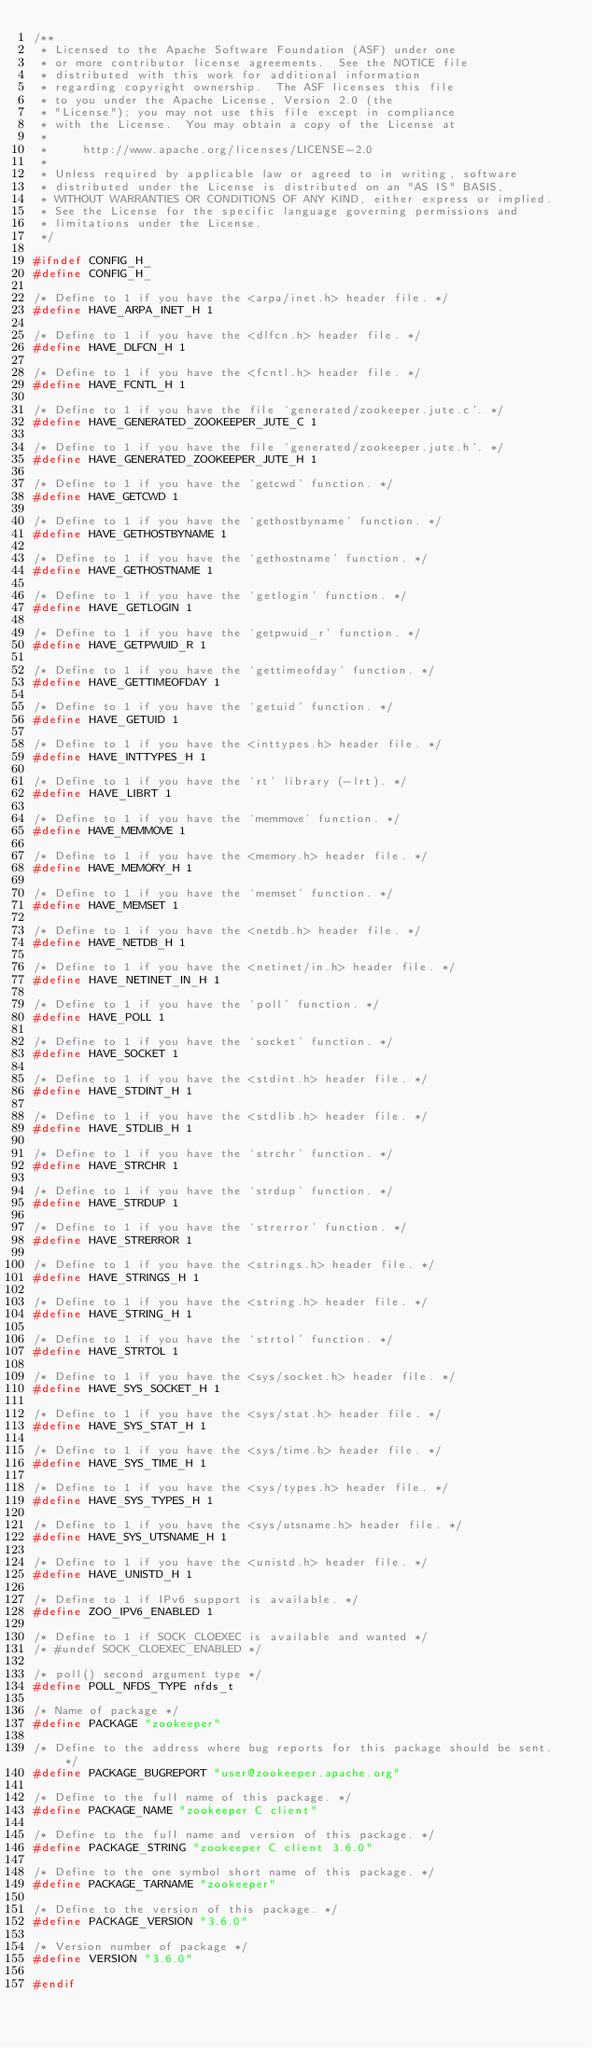<code> <loc_0><loc_0><loc_500><loc_500><_C_>/**
 * Licensed to the Apache Software Foundation (ASF) under one
 * or more contributor license agreements.  See the NOTICE file
 * distributed with this work for additional information
 * regarding copyright ownership.  The ASF licenses this file
 * to you under the Apache License, Version 2.0 (the
 * "License"); you may not use this file except in compliance
 * with the License.  You may obtain a copy of the License at
 *
 *     http://www.apache.org/licenses/LICENSE-2.0
 *
 * Unless required by applicable law or agreed to in writing, software
 * distributed under the License is distributed on an "AS IS" BASIS,
 * WITHOUT WARRANTIES OR CONDITIONS OF ANY KIND, either express or implied.
 * See the License for the specific language governing permissions and
 * limitations under the License.
 */

#ifndef CONFIG_H_
#define CONFIG_H_

/* Define to 1 if you have the <arpa/inet.h> header file. */
#define HAVE_ARPA_INET_H 1

/* Define to 1 if you have the <dlfcn.h> header file. */
#define HAVE_DLFCN_H 1

/* Define to 1 if you have the <fcntl.h> header file. */
#define HAVE_FCNTL_H 1

/* Define to 1 if you have the file `generated/zookeeper.jute.c'. */
#define HAVE_GENERATED_ZOOKEEPER_JUTE_C 1

/* Define to 1 if you have the file `generated/zookeeper.jute.h'. */
#define HAVE_GENERATED_ZOOKEEPER_JUTE_H 1

/* Define to 1 if you have the `getcwd' function. */
#define HAVE_GETCWD 1

/* Define to 1 if you have the `gethostbyname' function. */
#define HAVE_GETHOSTBYNAME 1

/* Define to 1 if you have the `gethostname' function. */
#define HAVE_GETHOSTNAME 1

/* Define to 1 if you have the `getlogin' function. */
#define HAVE_GETLOGIN 1

/* Define to 1 if you have the `getpwuid_r' function. */
#define HAVE_GETPWUID_R 1

/* Define to 1 if you have the `gettimeofday' function. */
#define HAVE_GETTIMEOFDAY 1

/* Define to 1 if you have the `getuid' function. */
#define HAVE_GETUID 1

/* Define to 1 if you have the <inttypes.h> header file. */
#define HAVE_INTTYPES_H 1

/* Define to 1 if you have the `rt' library (-lrt). */
#define HAVE_LIBRT 1

/* Define to 1 if you have the `memmove' function. */
#define HAVE_MEMMOVE 1

/* Define to 1 if you have the <memory.h> header file. */
#define HAVE_MEMORY_H 1

/* Define to 1 if you have the `memset' function. */
#define HAVE_MEMSET 1

/* Define to 1 if you have the <netdb.h> header file. */
#define HAVE_NETDB_H 1

/* Define to 1 if you have the <netinet/in.h> header file. */
#define HAVE_NETINET_IN_H 1

/* Define to 1 if you have the `poll' function. */
#define HAVE_POLL 1

/* Define to 1 if you have the `socket' function. */
#define HAVE_SOCKET 1

/* Define to 1 if you have the <stdint.h> header file. */
#define HAVE_STDINT_H 1

/* Define to 1 if you have the <stdlib.h> header file. */
#define HAVE_STDLIB_H 1

/* Define to 1 if you have the `strchr' function. */
#define HAVE_STRCHR 1

/* Define to 1 if you have the `strdup' function. */
#define HAVE_STRDUP 1

/* Define to 1 if you have the `strerror' function. */
#define HAVE_STRERROR 1

/* Define to 1 if you have the <strings.h> header file. */
#define HAVE_STRINGS_H 1

/* Define to 1 if you have the <string.h> header file. */
#define HAVE_STRING_H 1

/* Define to 1 if you have the `strtol' function. */
#define HAVE_STRTOL 1

/* Define to 1 if you have the <sys/socket.h> header file. */
#define HAVE_SYS_SOCKET_H 1

/* Define to 1 if you have the <sys/stat.h> header file. */
#define HAVE_SYS_STAT_H 1

/* Define to 1 if you have the <sys/time.h> header file. */
#define HAVE_SYS_TIME_H 1

/* Define to 1 if you have the <sys/types.h> header file. */
#define HAVE_SYS_TYPES_H 1

/* Define to 1 if you have the <sys/utsname.h> header file. */
#define HAVE_SYS_UTSNAME_H 1

/* Define to 1 if you have the <unistd.h> header file. */
#define HAVE_UNISTD_H 1

/* Define to 1 if IPv6 support is available. */
#define ZOO_IPV6_ENABLED 1

/* Define to 1 if SOCK_CLOEXEC is available and wanted */
/* #undef SOCK_CLOEXEC_ENABLED */

/* poll() second argument type */
#define POLL_NFDS_TYPE nfds_t

/* Name of package */
#define PACKAGE "zookeeper"

/* Define to the address where bug reports for this package should be sent. */
#define PACKAGE_BUGREPORT "user@zookeeper.apache.org"

/* Define to the full name of this package. */
#define PACKAGE_NAME "zookeeper C client"

/* Define to the full name and version of this package. */
#define PACKAGE_STRING "zookeeper C client 3.6.0"

/* Define to the one symbol short name of this package. */
#define PACKAGE_TARNAME "zookeeper"

/* Define to the version of this package. */
#define PACKAGE_VERSION "3.6.0"

/* Version number of package */
#define VERSION "3.6.0"

#endif
</code> 